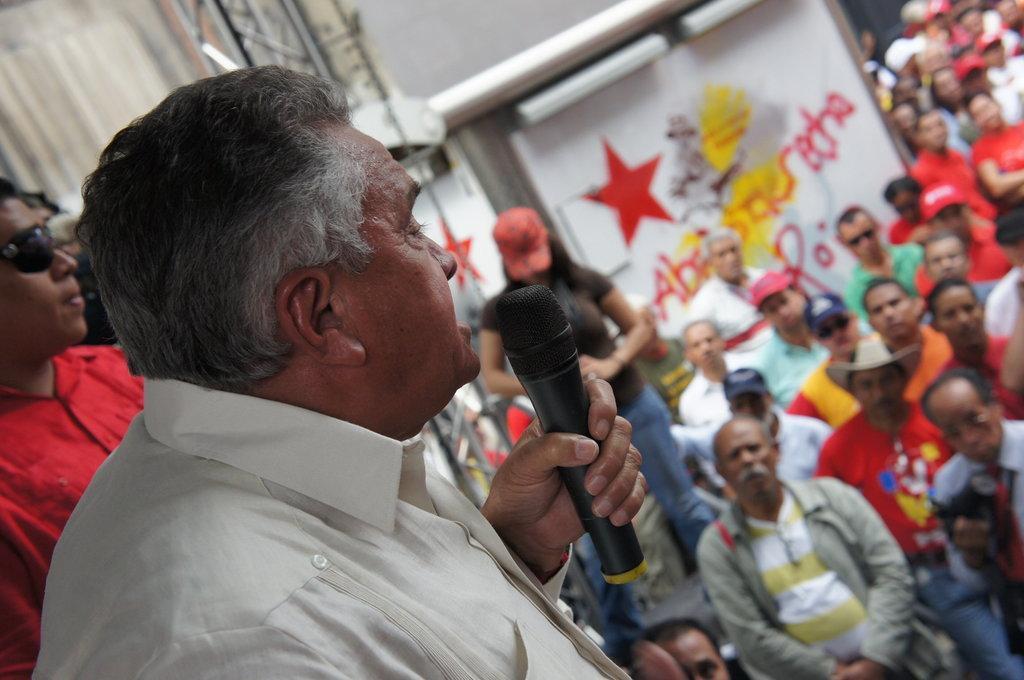In one or two sentences, can you explain what this image depicts? In this picture I can see a man holding a mike. There are group of people. I can see a truss, and in the background there are some objects. 